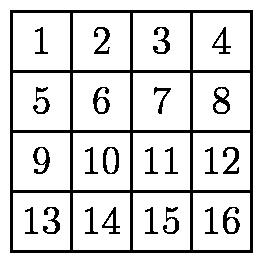Can you explain other possible outcomes had the folding sequence started differently? Certainly! If the sequence of folds were to start horizontally instead of vertically, or if the right half was folded over the left before any vertical folds took place, different numbers might end on the top after all folds are completed. Each change in the sequence alters the final topmost position, dependent on the order and direction of the folds. Experimenting with alternative folding sequences could lead to a variety of outcomes, showcasing the impact of initial and ongoing choices in the folding process. 